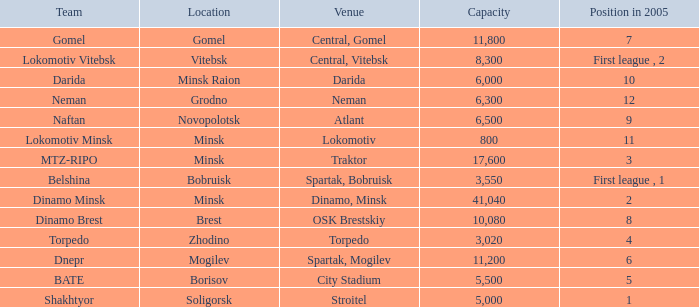Can you tell me the Capacity that has the Position in 2005 of 8? 10080.0. 